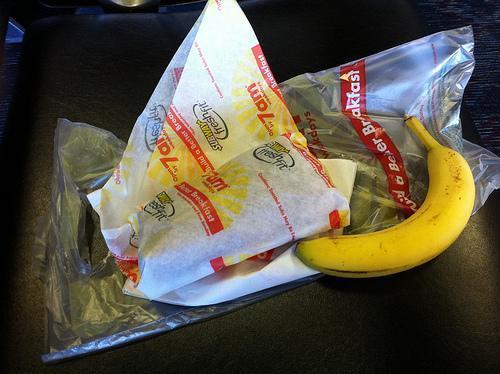How many bananas are shown?
Give a very brief answer. 1. 